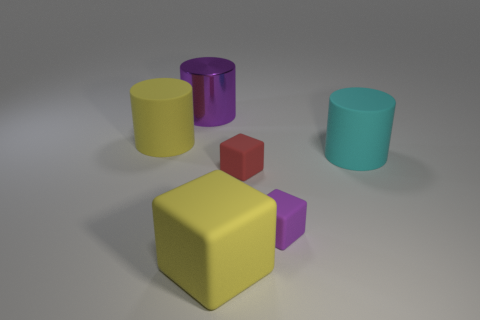Is there a pattern to the arrangement of these objects? The objects are arranged without a discernible pattern; they are placed at varied distances and angles from one another. The arrangement appears random rather than following a specific geometric or symmetrical order. 